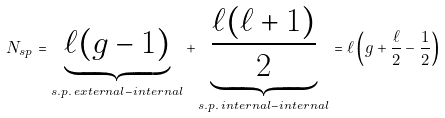Convert formula to latex. <formula><loc_0><loc_0><loc_500><loc_500>N _ { s p } = \underbrace { \ell ( g - 1 ) } _ { s . p . \, e x t e r n a l - i n t e r n a l } + \underbrace { \frac { \ell ( \ell + 1 ) } { 2 } } _ { s . p . \, i n t e r n a l - i n t e r n a l } = \ell \left ( g + \frac { \ell } { 2 } - \frac { 1 } { 2 } \right )</formula> 